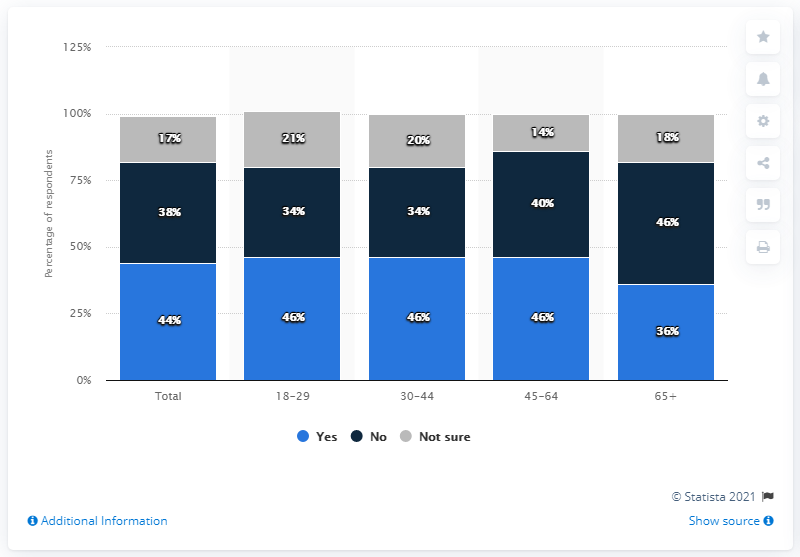Highlight a few significant elements in this photo. The 65+ age group has the least share of "Yes" responses. The total percentage of "Yes" and "No" responses among those aged 18-29 is 80%. 